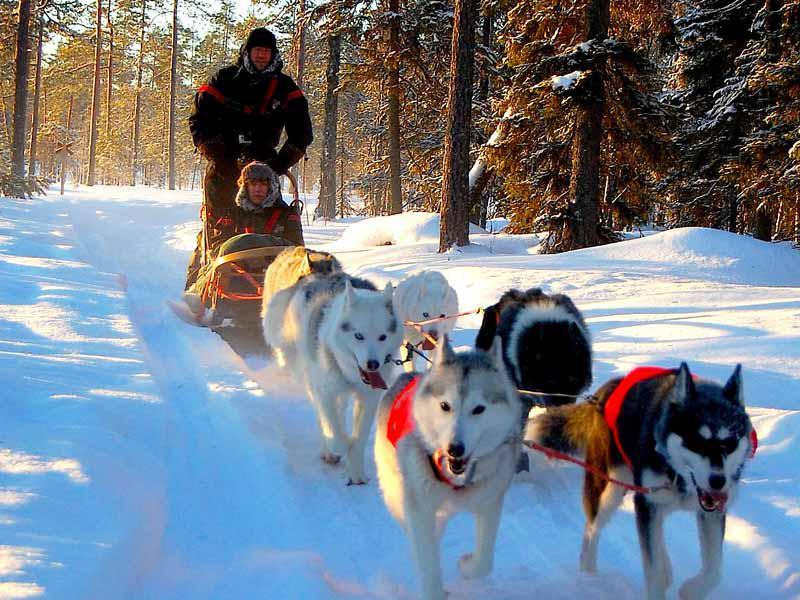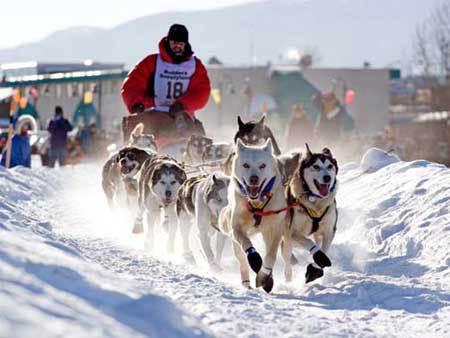The first image is the image on the left, the second image is the image on the right. Evaluate the accuracy of this statement regarding the images: "There are two huskies strapped next to each other on the snow.". Is it true? Answer yes or no. No. The first image is the image on the left, the second image is the image on the right. Given the left and right images, does the statement "In the right image, crowds of people are standing behind a dog sled team driven by a man in a vest and headed forward." hold true? Answer yes or no. Yes. 